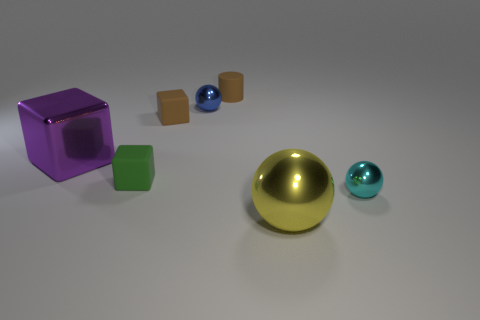There is a green rubber thing that is the same size as the blue object; what is its shape? The green rubber object is a cube, which shares its dimensions with the blue sphere, indicating that they are of the same size. 